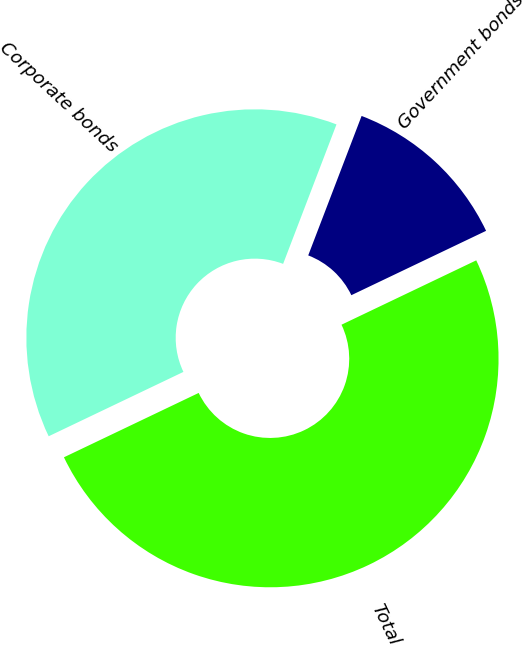Convert chart to OTSL. <chart><loc_0><loc_0><loc_500><loc_500><pie_chart><fcel>Government bonds<fcel>Corporate bonds<fcel>Total<nl><fcel>12.09%<fcel>37.91%<fcel>50.0%<nl></chart> 